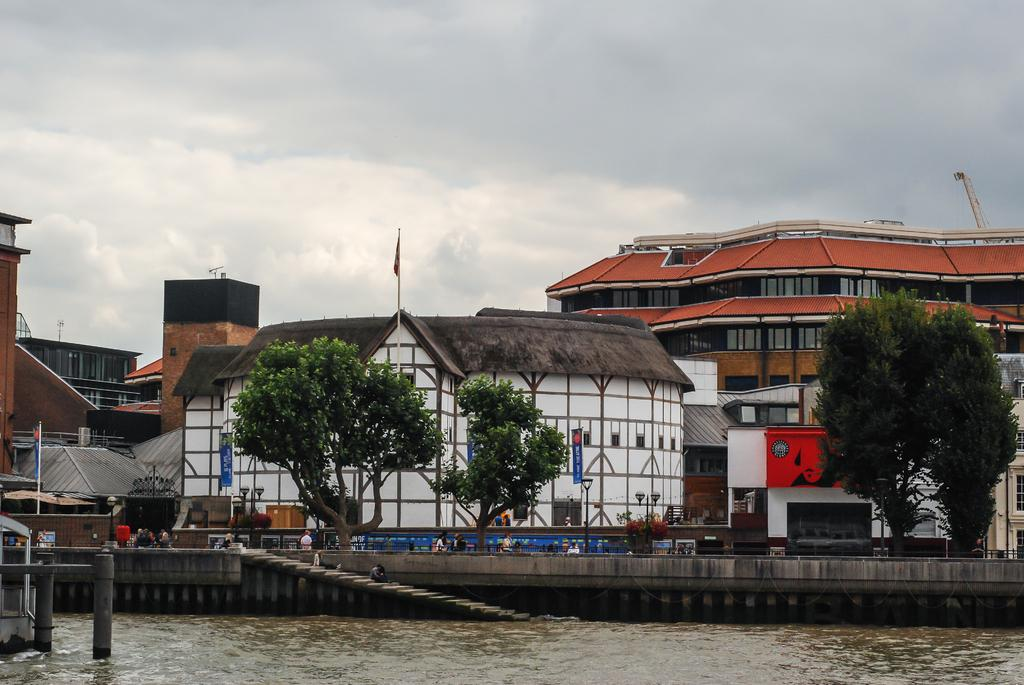What type of location is shown in the image? The image depicts a city. What natural element can be seen in the image? There is water in the image. What type of vegetation is present in the image? There are trees in the image. What structures are used to display flags in the image? There are flags with poles in the image. Who is present in the image? There is a group of people in the image. What type of man-made structures are visible in the image? There are buildings in the image. What type of illumination is present in the image? There are lights in the image. What can be seen in the background of the image? The sky is visible in the background of the image. How many tanks are visible in the image? There are no tanks present in the image. What type of parent is shown interacting with the group of people in the image? There is no parent shown interacting with the group of people in the image. 